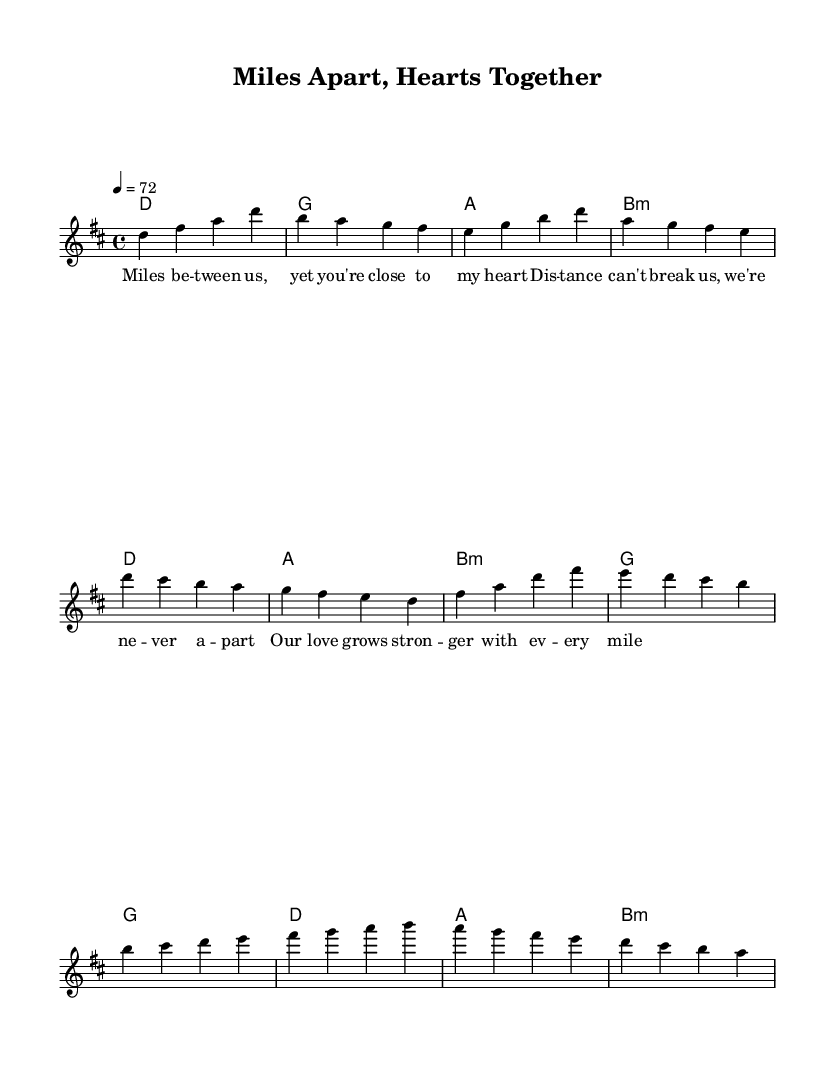What is the key signature of this music? The key signature is D major, which has two sharps (F# and C#).
Answer: D major What is the time signature of this music? The time signature is 4/4, meaning there are four beats in each measure.
Answer: 4/4 What is the tempo marking for this piece? The tempo marking is quarter note = 72, indicating the speed of the piece.
Answer: 72 How many measures are in the verse section? The verse section has four measures as indicated in the melody line.
Answer: Four What kind of chord follows the G chord in the verse? The chord following the G chord is A, as represented in the chord progression.
Answer: A In which section does the line "Our love grows stronger with every mile" appear? This line appears in the bridge section of the song, according to the organization of the lyrics.
Answer: Bridge What is the primary theme of this ballad? The primary theme of this ballad is long-distance love, as reflected in the lyrics and emotional tone.
Answer: Long-distance love 